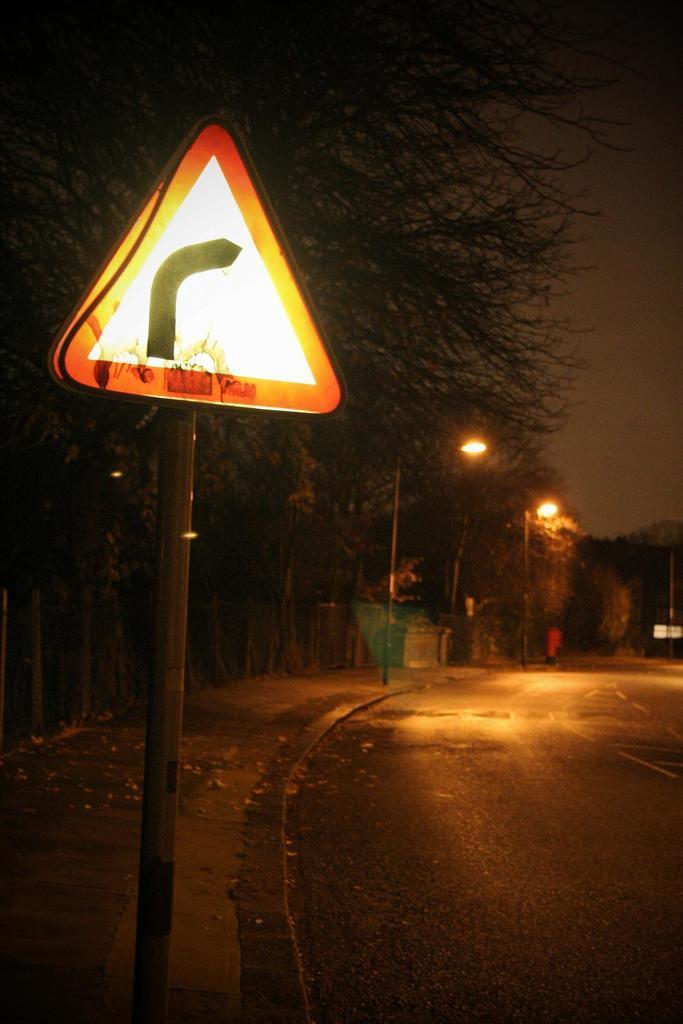In one or two sentences, can you explain what this image depicts? In this image in front there is a road. On the left side of the image there is a pavement. There is a directional board. There are poles. There are street lights and a few other objects. In the background of the image there are trees and sky. 